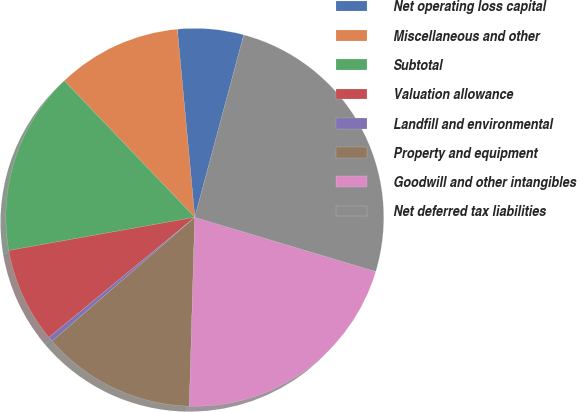<chart> <loc_0><loc_0><loc_500><loc_500><pie_chart><fcel>Net operating loss capital<fcel>Miscellaneous and other<fcel>Subtotal<fcel>Valuation allowance<fcel>Landfill and environmental<fcel>Property and equipment<fcel>Goodwill and other intangibles<fcel>Net deferred tax liabilities<nl><fcel>5.65%<fcel>10.66%<fcel>15.67%<fcel>8.15%<fcel>0.42%<fcel>13.16%<fcel>20.83%<fcel>25.46%<nl></chart> 